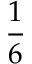<formula> <loc_0><loc_0><loc_500><loc_500>\frac { 1 } { 6 }</formula> 